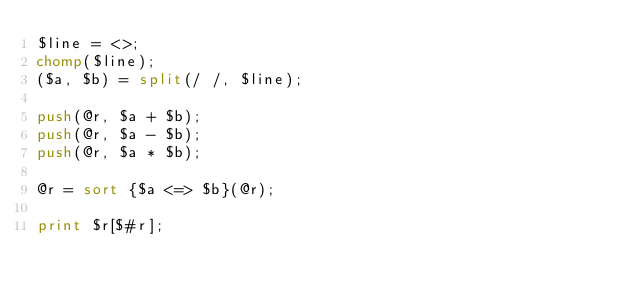<code> <loc_0><loc_0><loc_500><loc_500><_Perl_>$line = <>;
chomp($line);
($a, $b) = split(/ /, $line);

push(@r, $a + $b);
push(@r, $a - $b);
push(@r, $a * $b);

@r = sort {$a <=> $b}(@r);

print $r[$#r];
</code> 